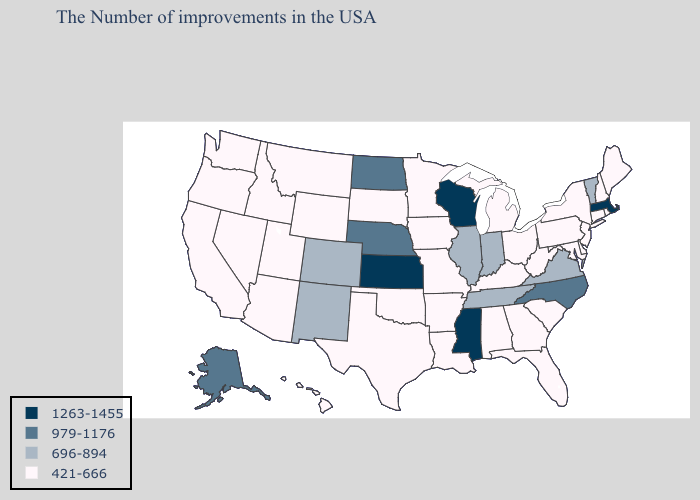Does Massachusetts have a higher value than Mississippi?
Write a very short answer. No. Does Colorado have the same value as Arizona?
Give a very brief answer. No. Among the states that border New Hampshire , does Vermont have the highest value?
Answer briefly. No. Does Kentucky have a lower value than Maryland?
Keep it brief. No. Among the states that border Michigan , does Ohio have the lowest value?
Short answer required. Yes. What is the value of Missouri?
Quick response, please. 421-666. Does the map have missing data?
Keep it brief. No. Which states have the highest value in the USA?
Be succinct. Massachusetts, Wisconsin, Mississippi, Kansas. Does Alabama have the lowest value in the USA?
Quick response, please. Yes. Does Florida have a higher value than California?
Write a very short answer. No. Does Mississippi have the highest value in the South?
Give a very brief answer. Yes. What is the value of Vermont?
Concise answer only. 696-894. Name the states that have a value in the range 1263-1455?
Answer briefly. Massachusetts, Wisconsin, Mississippi, Kansas. What is the value of Alaska?
Quick response, please. 979-1176. Which states hav the highest value in the MidWest?
Be succinct. Wisconsin, Kansas. 